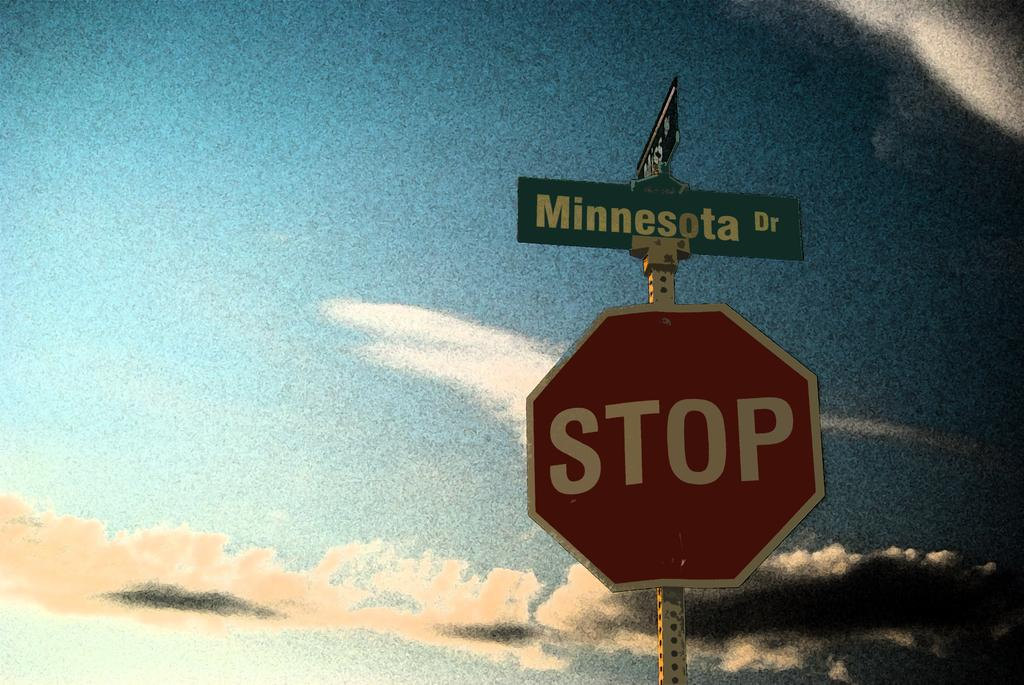Provide a one-sentence caption for the provided image. A stop sign below the street sign of Minnesota Dr. 